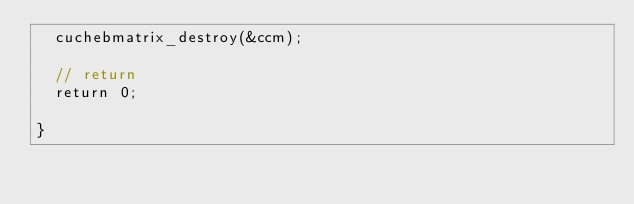Convert code to text. <code><loc_0><loc_0><loc_500><loc_500><_Cuda_>  cuchebmatrix_destroy(&ccm);

  // return 
  return 0;

}
</code> 